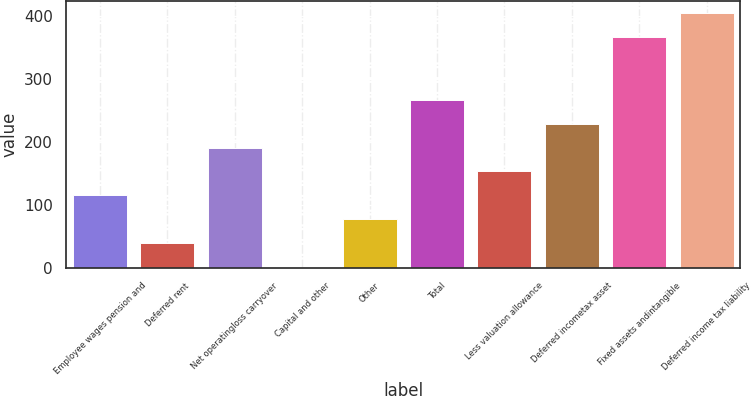<chart> <loc_0><loc_0><loc_500><loc_500><bar_chart><fcel>Employee wages pension and<fcel>Deferred rent<fcel>Net operatingloss carryover<fcel>Capital and other<fcel>Other<fcel>Total<fcel>Less valuation allowance<fcel>Deferred incometax asset<fcel>Fixed assets andintangible<fcel>Deferred income tax liability<nl><fcel>115.29<fcel>39.83<fcel>190.75<fcel>2.1<fcel>77.56<fcel>266.21<fcel>153.02<fcel>228.48<fcel>366.2<fcel>403.93<nl></chart> 